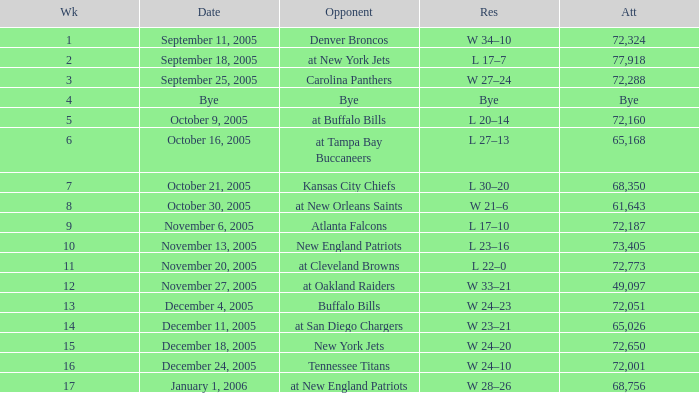Who was the Opponent on November 27, 2005? At oakland raiders. 